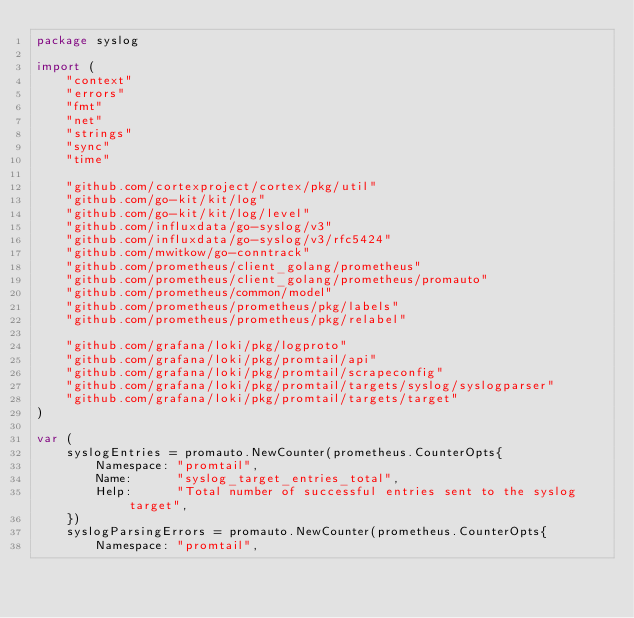<code> <loc_0><loc_0><loc_500><loc_500><_Go_>package syslog

import (
	"context"
	"errors"
	"fmt"
	"net"
	"strings"
	"sync"
	"time"

	"github.com/cortexproject/cortex/pkg/util"
	"github.com/go-kit/kit/log"
	"github.com/go-kit/kit/log/level"
	"github.com/influxdata/go-syslog/v3"
	"github.com/influxdata/go-syslog/v3/rfc5424"
	"github.com/mwitkow/go-conntrack"
	"github.com/prometheus/client_golang/prometheus"
	"github.com/prometheus/client_golang/prometheus/promauto"
	"github.com/prometheus/common/model"
	"github.com/prometheus/prometheus/pkg/labels"
	"github.com/prometheus/prometheus/pkg/relabel"

	"github.com/grafana/loki/pkg/logproto"
	"github.com/grafana/loki/pkg/promtail/api"
	"github.com/grafana/loki/pkg/promtail/scrapeconfig"
	"github.com/grafana/loki/pkg/promtail/targets/syslog/syslogparser"
	"github.com/grafana/loki/pkg/promtail/targets/target"
)

var (
	syslogEntries = promauto.NewCounter(prometheus.CounterOpts{
		Namespace: "promtail",
		Name:      "syslog_target_entries_total",
		Help:      "Total number of successful entries sent to the syslog target",
	})
	syslogParsingErrors = promauto.NewCounter(prometheus.CounterOpts{
		Namespace: "promtail",</code> 